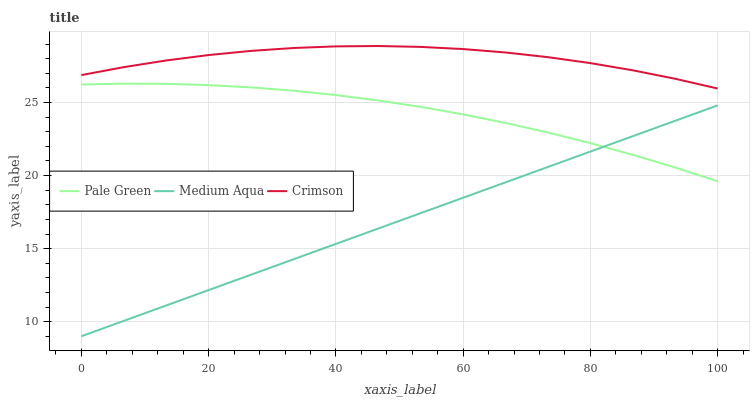Does Pale Green have the minimum area under the curve?
Answer yes or no. No. Does Pale Green have the maximum area under the curve?
Answer yes or no. No. Is Pale Green the smoothest?
Answer yes or no. No. Is Pale Green the roughest?
Answer yes or no. No. Does Pale Green have the lowest value?
Answer yes or no. No. Does Pale Green have the highest value?
Answer yes or no. No. Is Pale Green less than Crimson?
Answer yes or no. Yes. Is Crimson greater than Medium Aqua?
Answer yes or no. Yes. Does Pale Green intersect Crimson?
Answer yes or no. No. 